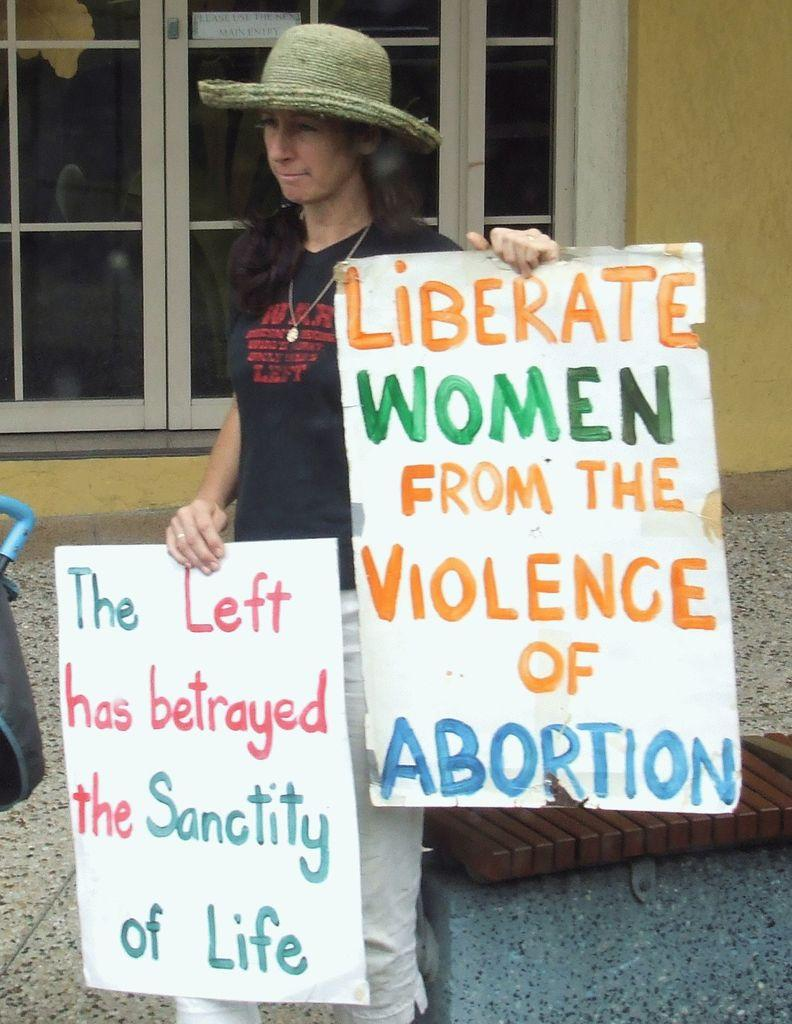Who is present in the image? There is a woman in the image. What is the woman holding in the image? The woman is holding posters. What is the woman wearing on her head? The woman is wearing a hat. What type of surface is visible in the image? There is a floor visible in the image. What can be seen in the background of the image? There is a wall and a door in the background of the image. What type of church can be seen in the background of the image? There is no church present in the image; only a wall and a door are visible in the background. 